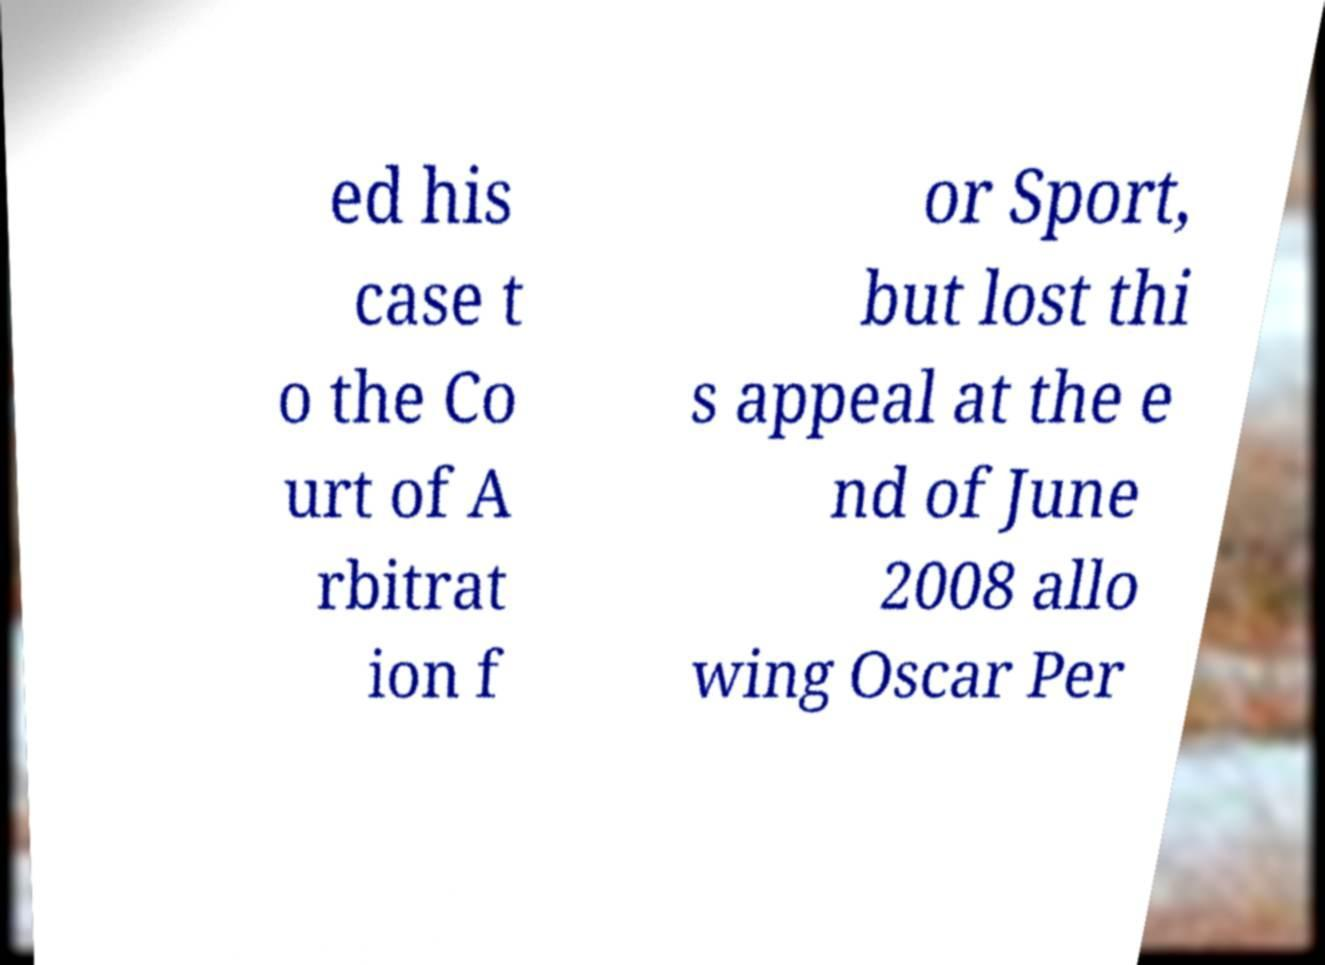I need the written content from this picture converted into text. Can you do that? ed his case t o the Co urt of A rbitrat ion f or Sport, but lost thi s appeal at the e nd of June 2008 allo wing Oscar Per 